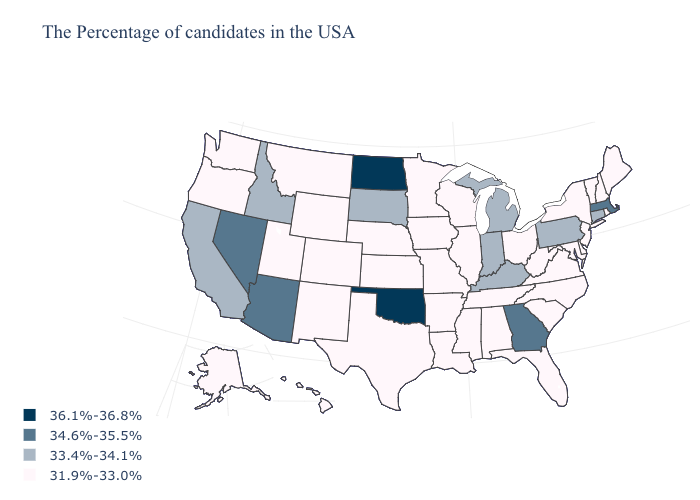Name the states that have a value in the range 36.1%-36.8%?
Be succinct. Oklahoma, North Dakota. What is the value of Oklahoma?
Short answer required. 36.1%-36.8%. What is the lowest value in the South?
Be succinct. 31.9%-33.0%. Does New Jersey have the same value as California?
Concise answer only. No. What is the value of Wyoming?
Give a very brief answer. 31.9%-33.0%. Name the states that have a value in the range 36.1%-36.8%?
Give a very brief answer. Oklahoma, North Dakota. What is the value of Louisiana?
Answer briefly. 31.9%-33.0%. Name the states that have a value in the range 36.1%-36.8%?
Concise answer only. Oklahoma, North Dakota. Name the states that have a value in the range 33.4%-34.1%?
Concise answer only. Connecticut, Pennsylvania, Michigan, Kentucky, Indiana, South Dakota, Idaho, California. What is the highest value in states that border New Hampshire?
Keep it brief. 34.6%-35.5%. Among the states that border Utah , does Colorado have the lowest value?
Concise answer only. Yes. Does the first symbol in the legend represent the smallest category?
Concise answer only. No. Name the states that have a value in the range 34.6%-35.5%?
Keep it brief. Massachusetts, Georgia, Arizona, Nevada. Does the first symbol in the legend represent the smallest category?
Concise answer only. No. What is the highest value in states that border Michigan?
Write a very short answer. 33.4%-34.1%. 